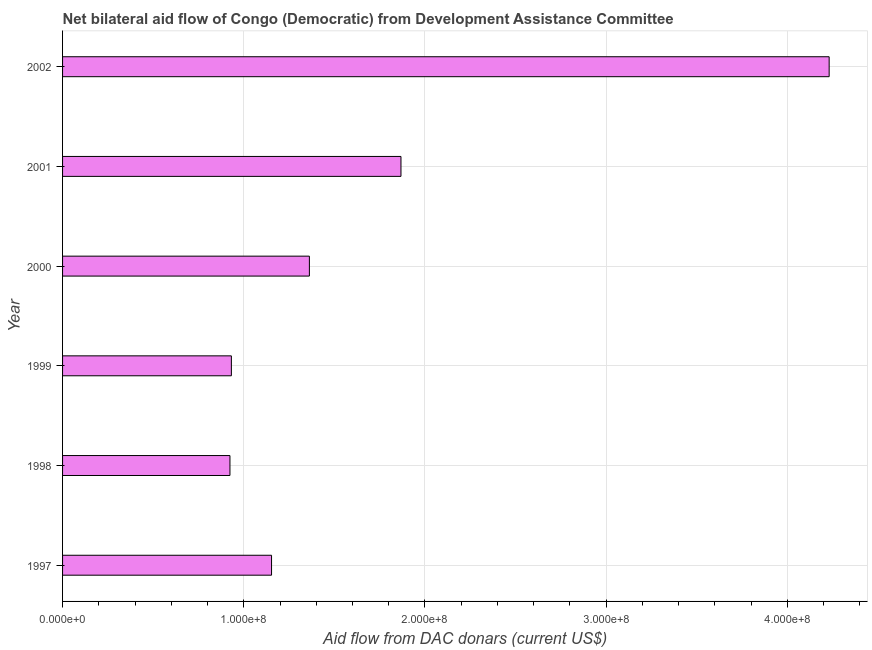What is the title of the graph?
Your answer should be compact. Net bilateral aid flow of Congo (Democratic) from Development Assistance Committee. What is the label or title of the X-axis?
Give a very brief answer. Aid flow from DAC donars (current US$). What is the net bilateral aid flows from dac donors in 2000?
Your answer should be compact. 1.36e+08. Across all years, what is the maximum net bilateral aid flows from dac donors?
Your answer should be very brief. 4.23e+08. Across all years, what is the minimum net bilateral aid flows from dac donors?
Offer a very short reply. 9.24e+07. In which year was the net bilateral aid flows from dac donors minimum?
Give a very brief answer. 1998. What is the sum of the net bilateral aid flows from dac donors?
Keep it short and to the point. 1.05e+09. What is the difference between the net bilateral aid flows from dac donors in 1999 and 2001?
Keep it short and to the point. -9.36e+07. What is the average net bilateral aid flows from dac donors per year?
Your answer should be very brief. 1.74e+08. What is the median net bilateral aid flows from dac donors?
Make the answer very short. 1.26e+08. What is the ratio of the net bilateral aid flows from dac donors in 1998 to that in 1999?
Provide a succinct answer. 0.99. Is the difference between the net bilateral aid flows from dac donors in 1999 and 2000 greater than the difference between any two years?
Provide a short and direct response. No. What is the difference between the highest and the second highest net bilateral aid flows from dac donors?
Make the answer very short. 2.36e+08. What is the difference between the highest and the lowest net bilateral aid flows from dac donors?
Ensure brevity in your answer.  3.31e+08. In how many years, is the net bilateral aid flows from dac donors greater than the average net bilateral aid flows from dac donors taken over all years?
Ensure brevity in your answer.  2. How many bars are there?
Give a very brief answer. 6. Are the values on the major ticks of X-axis written in scientific E-notation?
Offer a terse response. Yes. What is the Aid flow from DAC donars (current US$) in 1997?
Your answer should be compact. 1.15e+08. What is the Aid flow from DAC donars (current US$) in 1998?
Your answer should be very brief. 9.24e+07. What is the Aid flow from DAC donars (current US$) in 1999?
Your answer should be very brief. 9.32e+07. What is the Aid flow from DAC donars (current US$) of 2000?
Offer a terse response. 1.36e+08. What is the Aid flow from DAC donars (current US$) in 2001?
Provide a succinct answer. 1.87e+08. What is the Aid flow from DAC donars (current US$) in 2002?
Make the answer very short. 4.23e+08. What is the difference between the Aid flow from DAC donars (current US$) in 1997 and 1998?
Make the answer very short. 2.30e+07. What is the difference between the Aid flow from DAC donars (current US$) in 1997 and 1999?
Offer a terse response. 2.22e+07. What is the difference between the Aid flow from DAC donars (current US$) in 1997 and 2000?
Your answer should be very brief. -2.09e+07. What is the difference between the Aid flow from DAC donars (current US$) in 1997 and 2001?
Offer a terse response. -7.14e+07. What is the difference between the Aid flow from DAC donars (current US$) in 1997 and 2002?
Your response must be concise. -3.08e+08. What is the difference between the Aid flow from DAC donars (current US$) in 1998 and 1999?
Offer a terse response. -7.90e+05. What is the difference between the Aid flow from DAC donars (current US$) in 1998 and 2000?
Your response must be concise. -4.38e+07. What is the difference between the Aid flow from DAC donars (current US$) in 1998 and 2001?
Offer a terse response. -9.44e+07. What is the difference between the Aid flow from DAC donars (current US$) in 1998 and 2002?
Provide a succinct answer. -3.31e+08. What is the difference between the Aid flow from DAC donars (current US$) in 1999 and 2000?
Your answer should be compact. -4.30e+07. What is the difference between the Aid flow from DAC donars (current US$) in 1999 and 2001?
Make the answer very short. -9.36e+07. What is the difference between the Aid flow from DAC donars (current US$) in 1999 and 2002?
Make the answer very short. -3.30e+08. What is the difference between the Aid flow from DAC donars (current US$) in 2000 and 2001?
Offer a very short reply. -5.05e+07. What is the difference between the Aid flow from DAC donars (current US$) in 2000 and 2002?
Your answer should be compact. -2.87e+08. What is the difference between the Aid flow from DAC donars (current US$) in 2001 and 2002?
Provide a short and direct response. -2.36e+08. What is the ratio of the Aid flow from DAC donars (current US$) in 1997 to that in 1998?
Ensure brevity in your answer.  1.25. What is the ratio of the Aid flow from DAC donars (current US$) in 1997 to that in 1999?
Ensure brevity in your answer.  1.24. What is the ratio of the Aid flow from DAC donars (current US$) in 1997 to that in 2000?
Keep it short and to the point. 0.85. What is the ratio of the Aid flow from DAC donars (current US$) in 1997 to that in 2001?
Keep it short and to the point. 0.62. What is the ratio of the Aid flow from DAC donars (current US$) in 1997 to that in 2002?
Offer a very short reply. 0.27. What is the ratio of the Aid flow from DAC donars (current US$) in 1998 to that in 1999?
Provide a short and direct response. 0.99. What is the ratio of the Aid flow from DAC donars (current US$) in 1998 to that in 2000?
Offer a terse response. 0.68. What is the ratio of the Aid flow from DAC donars (current US$) in 1998 to that in 2001?
Give a very brief answer. 0.49. What is the ratio of the Aid flow from DAC donars (current US$) in 1998 to that in 2002?
Offer a terse response. 0.22. What is the ratio of the Aid flow from DAC donars (current US$) in 1999 to that in 2000?
Offer a terse response. 0.68. What is the ratio of the Aid flow from DAC donars (current US$) in 1999 to that in 2001?
Give a very brief answer. 0.5. What is the ratio of the Aid flow from DAC donars (current US$) in 1999 to that in 2002?
Give a very brief answer. 0.22. What is the ratio of the Aid flow from DAC donars (current US$) in 2000 to that in 2001?
Make the answer very short. 0.73. What is the ratio of the Aid flow from DAC donars (current US$) in 2000 to that in 2002?
Your answer should be very brief. 0.32. What is the ratio of the Aid flow from DAC donars (current US$) in 2001 to that in 2002?
Offer a terse response. 0.44. 